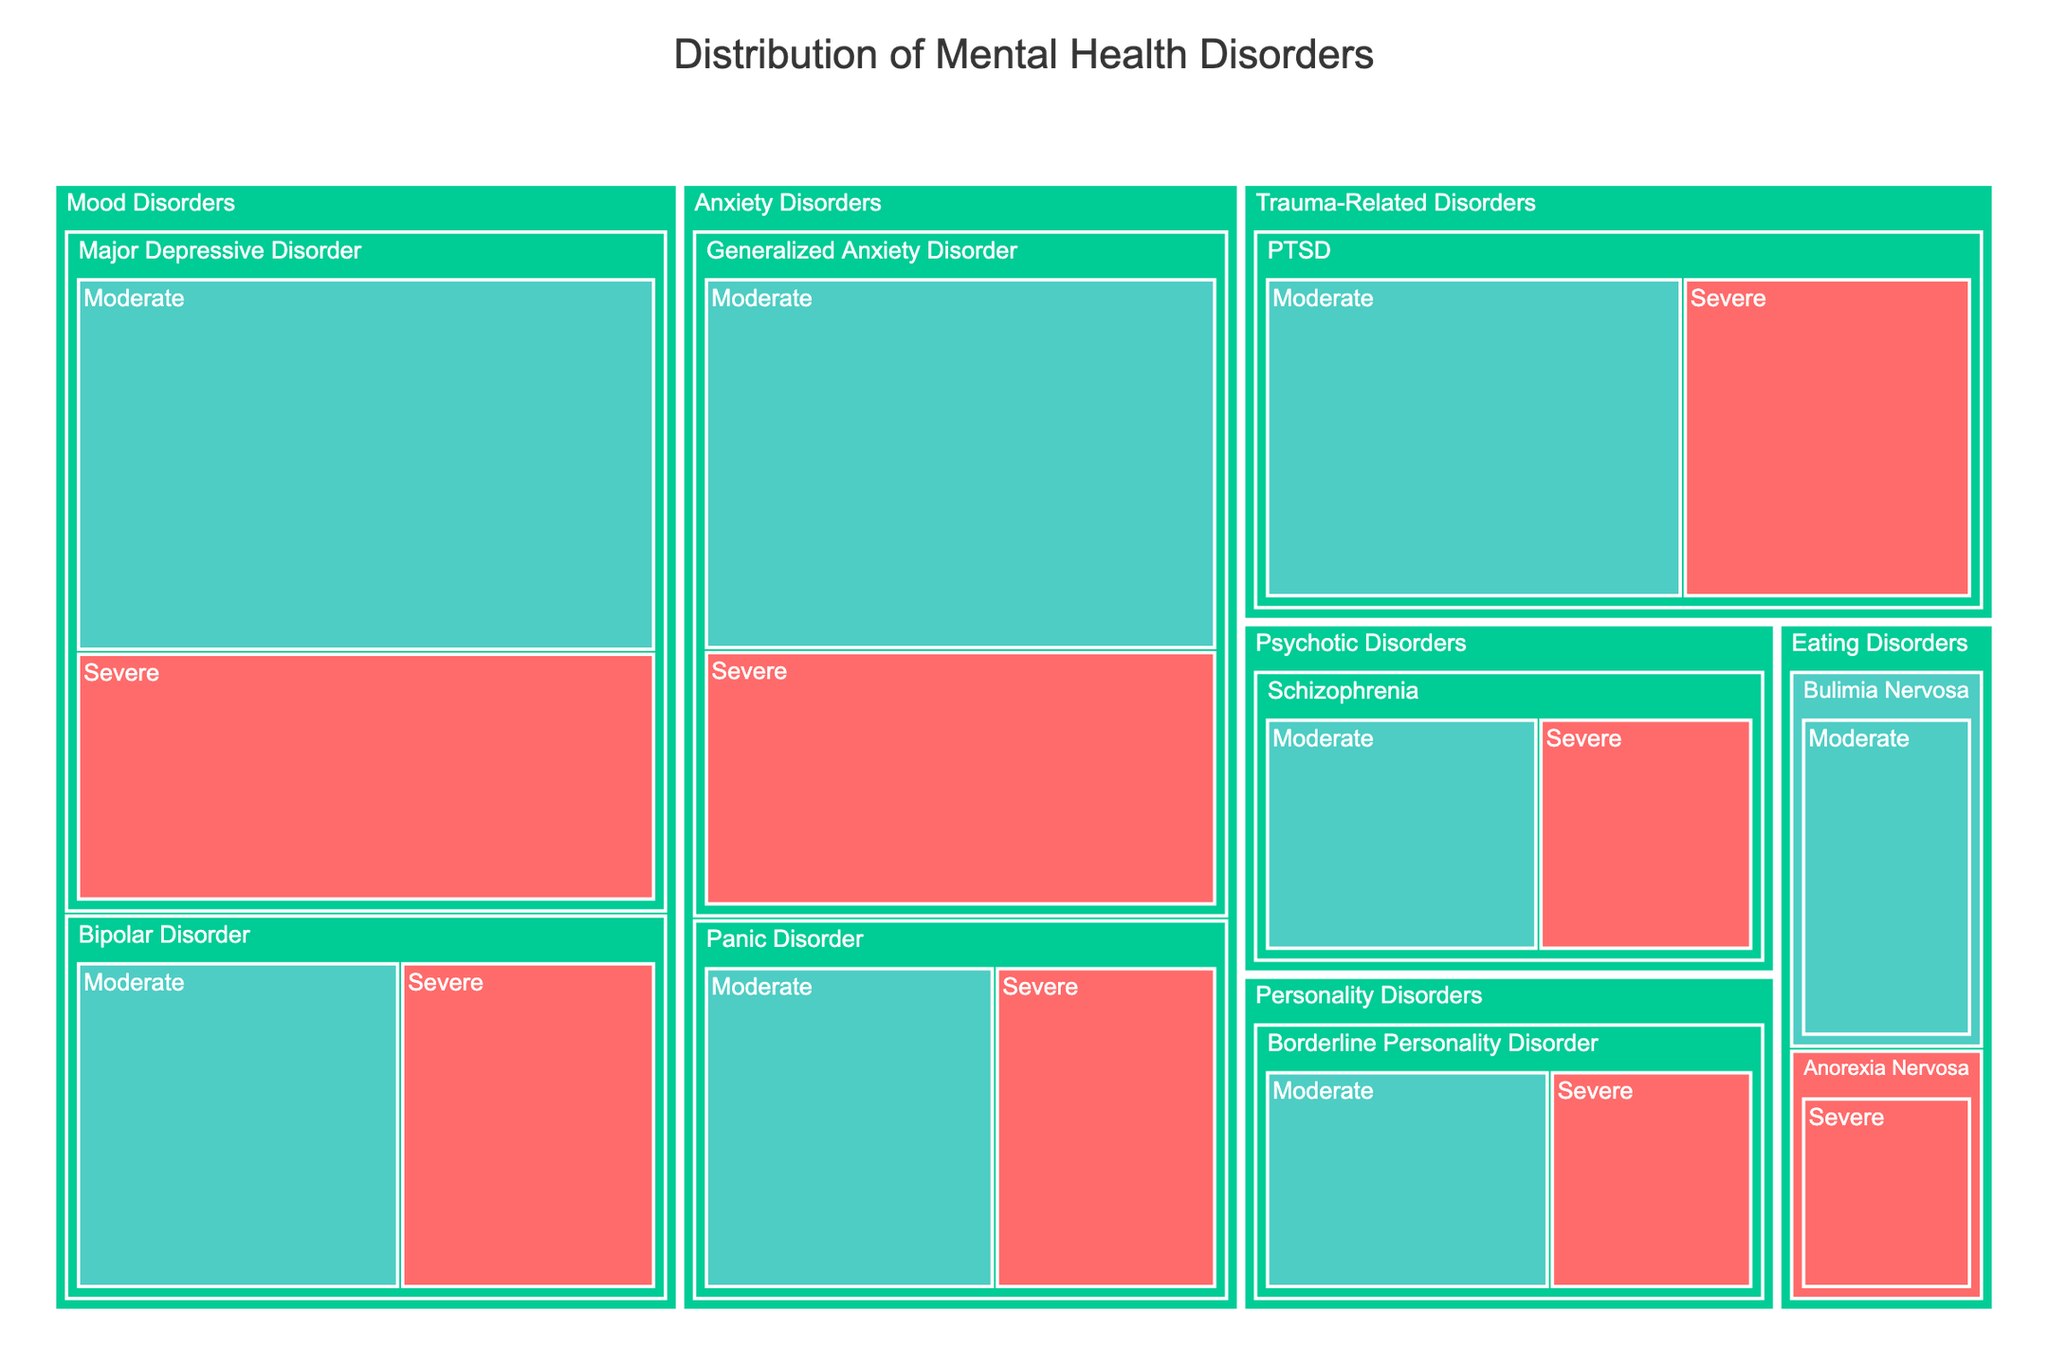what's the title of the figure? The title is usually displayed at the top and it's "Distribution of Mental Health Disorders".
Answer: Distribution of Mental Health Disorders How many categories are represented in the figure? Categories are the highest-level groups in a treemap. There are five categories: Mood Disorders, Anxiety Disorders, Trauma-Related Disorders, Psychotic Disorders, and Eating Disorders.
Answer: 5 What's the color used to represent 'Severe' severity? In the figure, the color key indicates that 'Severe' is represented by a specific red color.
Answer: Red What's the total number of patients with schizophrenia? Summing up patients for both severities within the schizophrenia disorder gives us 55 (Severe) + 70 (Moderate) = 125.
Answer: 125 Which disorder has the highest number of patients with moderate severity? By looking at the sizes and numbers in the treemap, Major Depressive Disorder (Moderate) has the highest number, which is 180.
Answer: Major Depressive Disorder What's the percentage of patients with severe panic disorder out of all anxiety disorders? First, find the total number of patients with anxiety disorders, which is 110 (Severe Generalized Anxiety Disorder) + 160 (Moderate Generalized Anxiety Disorder) + 65 (Severe Panic Disorder) + 85 (Moderate Panic Disorder) = 420. Then, calculate percentage: (65 / 420) * 100 = 15.48%.
Answer: 15.48% Compare the number of patients with PTSD to bipolar disorder. Which one has more patients? Summing up patients for PTSD (90 Severe + 130 Moderate = 220) and Bipolar Disorder (75 Severe + 95 Moderate = 170) shows that PTSD has more patients.
Answer: PTSD What's the difference in the number of patients between severe and moderate Borderline Personality Disorder? Subtract the number of moderate patients from severe: 70 (Moderate) - 50 (Severe) = 20.
Answer: 20 What proportion of mood disorders are classified as moderate severity? First, find the total number of patients in mood disorders: 120 (Severe Major Depressive) + 180 (Moderate Major Depressive) + 75 (Severe Bipolar) + 95 (Moderate Bipolar) = 470. Then the number of moderate severity in mood disorders is 180 (Major Depressive) + 95 (Bipolar) = 275. The proportion is (275 / 470) = 0.5851 or 58.51%.
Answer: 58.51% Which category consists of the lowest total number of patients? By summing up the patients in each category, the eating disorders category has the lowest, with 40 (Severe Anorexia) + 60 (Moderate Bulimia) = 100.
Answer: Eating Disorders 